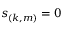<formula> <loc_0><loc_0><loc_500><loc_500>s _ { ( k , m ) } = 0</formula> 